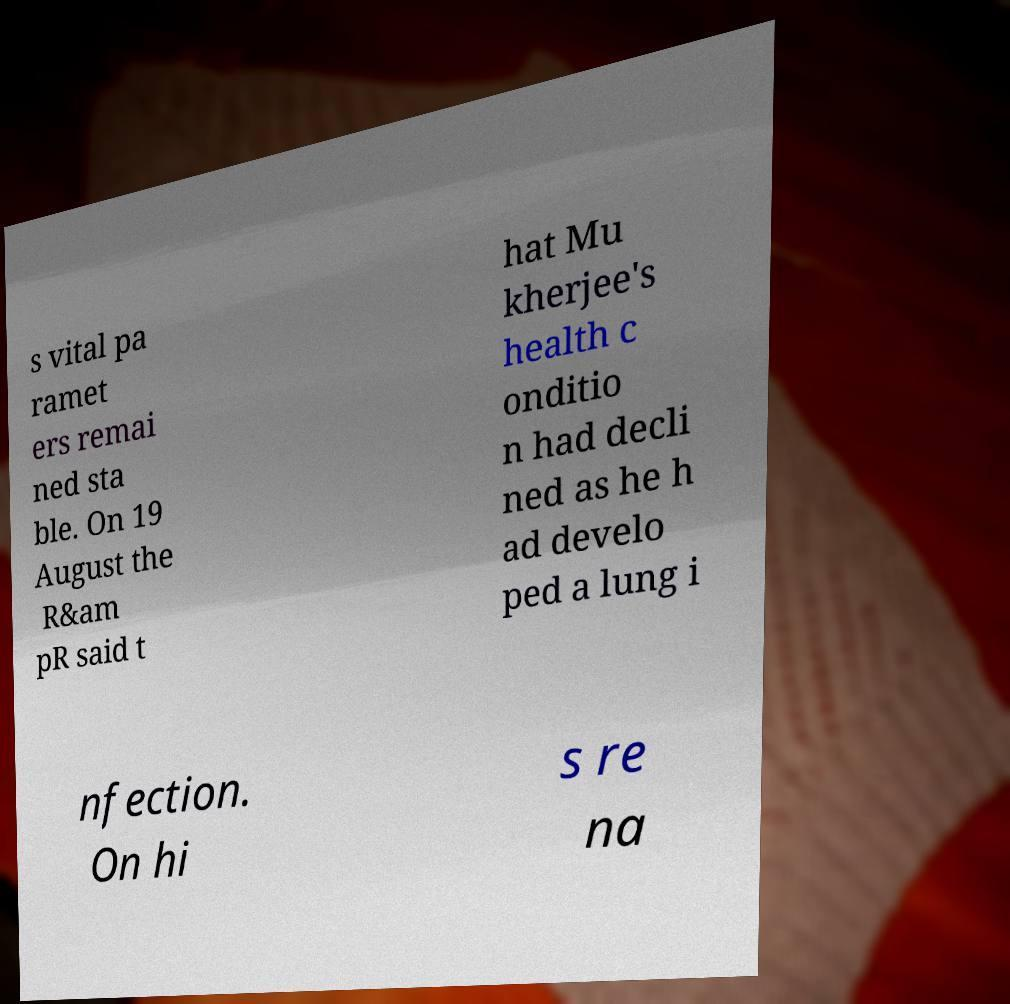Please identify and transcribe the text found in this image. s vital pa ramet ers remai ned sta ble. On 19 August the R&am pR said t hat Mu kherjee's health c onditio n had decli ned as he h ad develo ped a lung i nfection. On hi s re na 